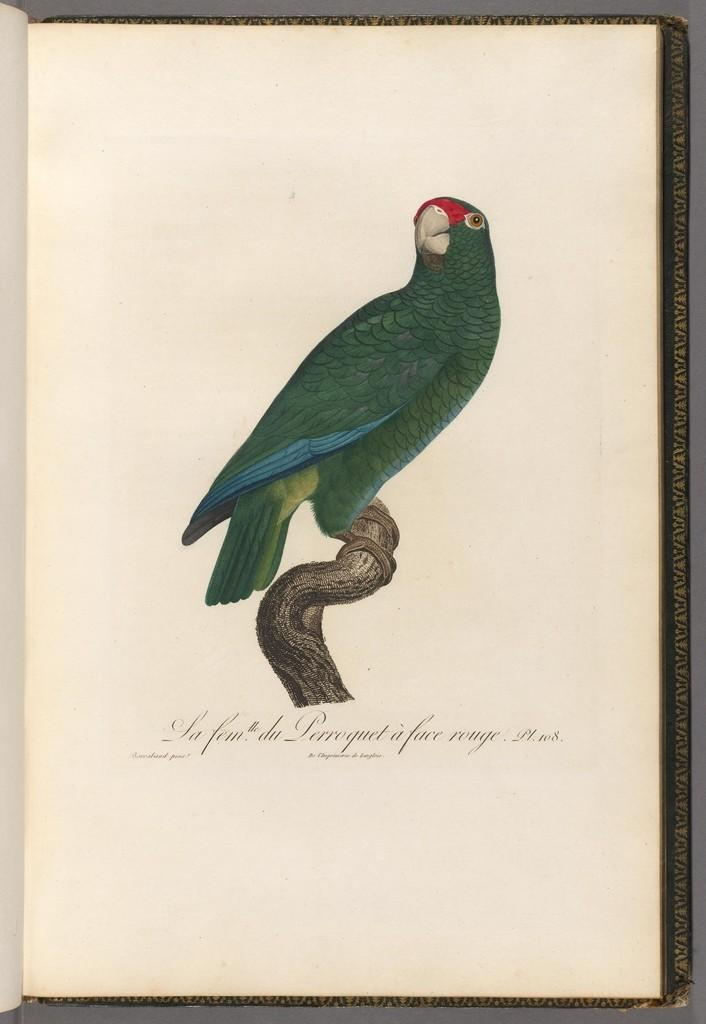What object is on the table in the image? There is a book on the table in the image. What is depicted on the page of the book? The page of the book has a parrot standing on a branch. Is there any text on the page of the book? Yes, there is a quotation at the bottom of the page. What type of thrill can be seen in the image? There is no thrill present in the image; it features a book with a page depicting a parrot standing on a branch. How many goldfish are visible in the image? There are no goldfish present in the image. 